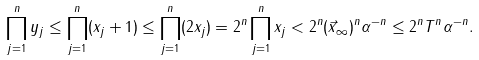<formula> <loc_0><loc_0><loc_500><loc_500>\prod _ { j = 1 } ^ { n } y _ { j } \leq \prod _ { j = 1 } ^ { n } ( x _ { j } + 1 ) \leq \prod _ { j = 1 } ^ { n } ( 2 x _ { j } ) = 2 ^ { n } \prod _ { j = 1 } ^ { n } x _ { j } < 2 ^ { n } ( \| \vec { x } \| _ { \infty } ) ^ { n } \alpha ^ { - n } \leq 2 ^ { n } T ^ { n } \alpha ^ { - n } .</formula> 